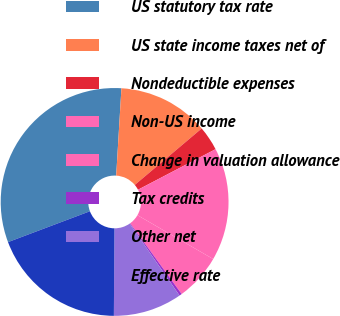Convert chart to OTSL. <chart><loc_0><loc_0><loc_500><loc_500><pie_chart><fcel>US statutory tax rate<fcel>US state income taxes net of<fcel>Nondeductible expenses<fcel>Non-US income<fcel>Change in valuation allowance<fcel>Tax credits<fcel>Other net<fcel>Effective rate<nl><fcel>31.69%<fcel>12.89%<fcel>3.49%<fcel>16.02%<fcel>6.63%<fcel>0.36%<fcel>9.76%<fcel>19.16%<nl></chart> 